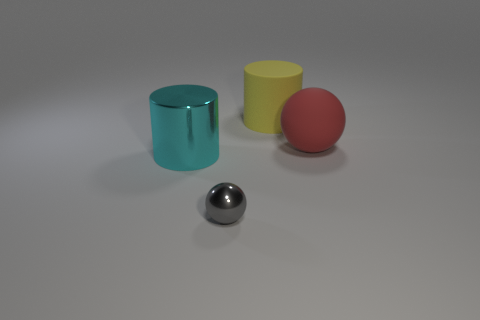Add 3 large gray metal spheres. How many objects exist? 7 Subtract all small yellow objects. Subtract all yellow rubber things. How many objects are left? 3 Add 4 matte spheres. How many matte spheres are left? 5 Add 3 green metal blocks. How many green metal blocks exist? 3 Subtract 0 blue cylinders. How many objects are left? 4 Subtract all purple cylinders. Subtract all red cubes. How many cylinders are left? 2 